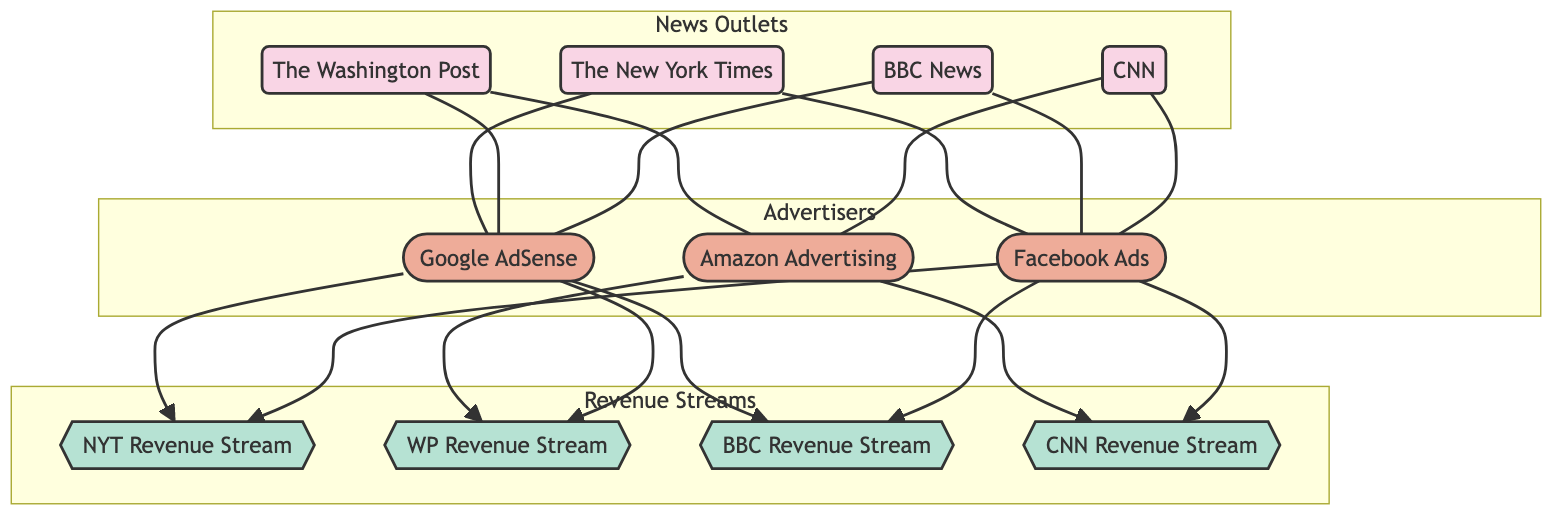What is the total number of nodes in the diagram? The diagram includes various nodes including news outlets, advertisers, and revenue streams. By counting all the distinct nodes listed (The New York Times, The Washington Post, BBC News, CNN, Google AdSense, Facebook Ads, Amazon Advertising, NYT Revenue Stream, WP Revenue Stream, BBC Revenue Stream, CNN Revenue Stream), we find a total of 11 nodes.
Answer: 11 Which advertiser is connected to The New York Times? The edges indicate the relationships between the nodes. Looking at the edges, we see that Google AdSense and Facebook Ads have an advertising partnership with The New York Times. Thus, the advertisers connected to it are Google AdSense and Facebook Ads.
Answer: Google AdSense, Facebook Ads How many revenue streams are listed in the diagram? The revenue streams are represented by separate nodes. Upon inspection, there are four revenue streams designated as NYT Revenue Stream, WP Revenue Stream, BBC Revenue Stream, and CNN Revenue Stream. Counting them gives us a total of four revenue streams.
Answer: 4 Which news outlet has a revenue stream linked only to Amazon Advertising? By examining the connections, the edge from Amazon Advertising leads to the revenue stream for The Washington Post. No other news outlets are linked solely to Amazon Advertising. Therefore, The Washington Post has a revenue stream linked only to Amazon Advertising.
Answer: The Washington Post What is the total number of edges in the diagram? The edges represent the relationships between nodes. By counting the listed edges (including advertising partnerships and revenue sources), we discover that there are 14 connections or edges in total.
Answer: 14 Which advertiser is connected to the BBC News outlet? The relationship edges indicate connections to various advertisers. Notably, BBC News has connections to Google AdSense and Facebook Ads, reflecting its partnerships with these advertisers.
Answer: Google AdSense, Facebook Ads How many revenue streams does CNN have? To determine this, we can count the edges stemming from the CNN node that direct toward revenue streams. There are two edges: one to the CNN Revenue Stream from Amazon Advertising and one from Facebook Ads. Hence, CNN has two revenue streams.
Answer: 2 What relationship connects the New York Times to its revenue streams? Looking at the edges from The New York Times, we can see that it has two edges leading to its revenue streams: one from Google AdSense and another from Facebook Ads. This means that both Google AdSense and Facebook Ads are revenue sources for The New York Times.
Answer: advertising_partnership Which two news outlets have the most advertiser connections? Upon reviewing the connections, both The New York Times and The Washington Post have two connections to their advertisers (New York Times with Google AdSense and Facebook Ads; Washington Post with Amazon Advertising and Google AdSense). Hence, they both have the most advertiser connections.
Answer: The New York Times, The Washington Post 